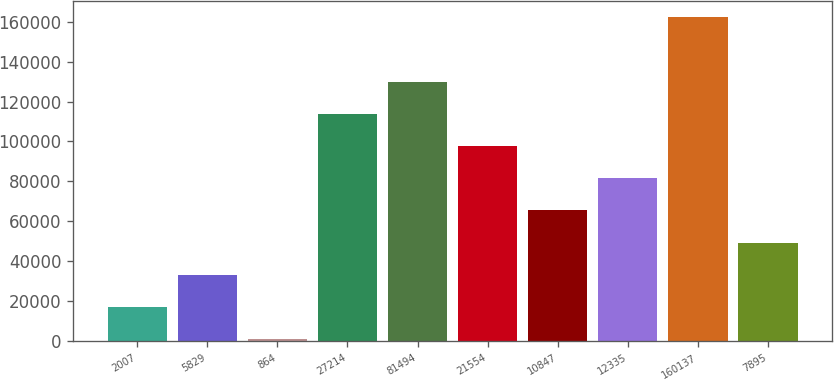Convert chart to OTSL. <chart><loc_0><loc_0><loc_500><loc_500><bar_chart><fcel>2007<fcel>5829<fcel>864<fcel>27214<fcel>81494<fcel>21554<fcel>10847<fcel>12335<fcel>160137<fcel>7895<nl><fcel>17044.2<fcel>33168.4<fcel>920<fcel>113789<fcel>129914<fcel>97665.2<fcel>65416.8<fcel>81541<fcel>162162<fcel>49292.6<nl></chart> 